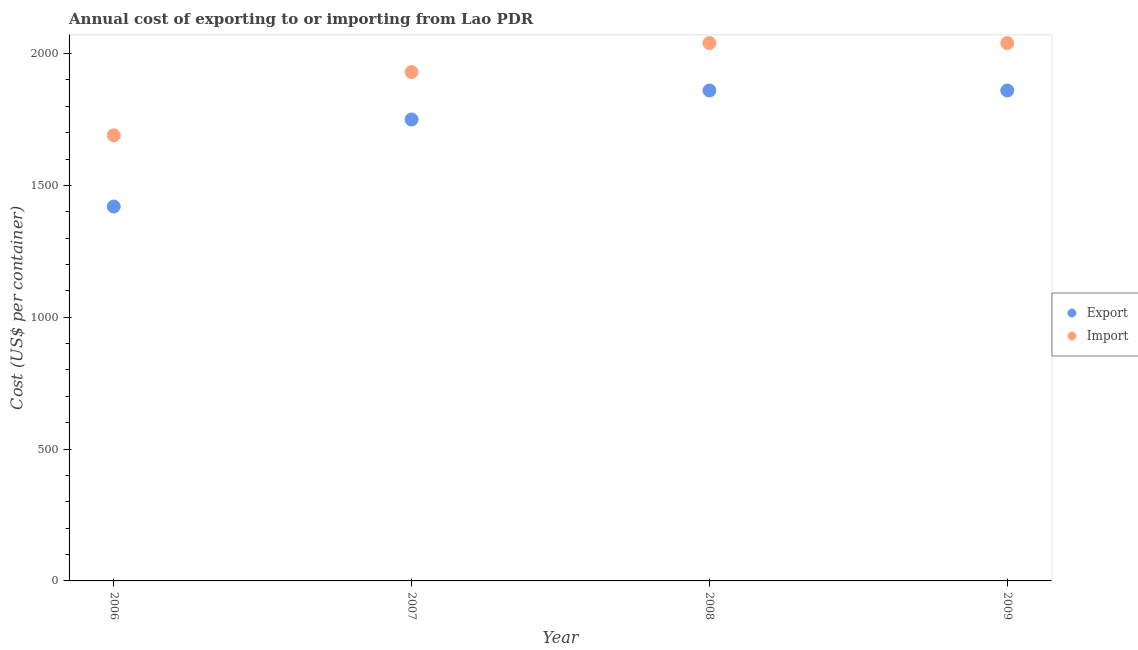How many different coloured dotlines are there?
Your answer should be very brief. 2. Is the number of dotlines equal to the number of legend labels?
Provide a succinct answer. Yes. What is the import cost in 2007?
Offer a very short reply. 1930. Across all years, what is the maximum export cost?
Provide a succinct answer. 1860. Across all years, what is the minimum import cost?
Keep it short and to the point. 1690. In which year was the import cost maximum?
Your answer should be compact. 2008. In which year was the import cost minimum?
Ensure brevity in your answer.  2006. What is the total export cost in the graph?
Keep it short and to the point. 6890. What is the difference between the import cost in 2007 and that in 2008?
Keep it short and to the point. -110. What is the difference between the export cost in 2007 and the import cost in 2009?
Provide a short and direct response. -290. What is the average import cost per year?
Keep it short and to the point. 1925. In the year 2009, what is the difference between the import cost and export cost?
Your response must be concise. 180. What is the ratio of the export cost in 2006 to that in 2007?
Provide a short and direct response. 0.81. Is the difference between the export cost in 2006 and 2009 greater than the difference between the import cost in 2006 and 2009?
Your response must be concise. No. What is the difference between the highest and the second highest import cost?
Your response must be concise. 0. What is the difference between the highest and the lowest import cost?
Provide a succinct answer. 350. In how many years, is the import cost greater than the average import cost taken over all years?
Make the answer very short. 3. Does the import cost monotonically increase over the years?
Give a very brief answer. No. Is the import cost strictly less than the export cost over the years?
Keep it short and to the point. No. What is the difference between two consecutive major ticks on the Y-axis?
Keep it short and to the point. 500. Are the values on the major ticks of Y-axis written in scientific E-notation?
Offer a very short reply. No. Does the graph contain any zero values?
Your answer should be very brief. No. Where does the legend appear in the graph?
Offer a terse response. Center right. How many legend labels are there?
Give a very brief answer. 2. What is the title of the graph?
Make the answer very short. Annual cost of exporting to or importing from Lao PDR. Does "Register a business" appear as one of the legend labels in the graph?
Make the answer very short. No. What is the label or title of the Y-axis?
Make the answer very short. Cost (US$ per container). What is the Cost (US$ per container) of Export in 2006?
Your answer should be compact. 1420. What is the Cost (US$ per container) of Import in 2006?
Offer a very short reply. 1690. What is the Cost (US$ per container) of Export in 2007?
Provide a succinct answer. 1750. What is the Cost (US$ per container) of Import in 2007?
Provide a succinct answer. 1930. What is the Cost (US$ per container) in Export in 2008?
Offer a terse response. 1860. What is the Cost (US$ per container) of Import in 2008?
Provide a succinct answer. 2040. What is the Cost (US$ per container) of Export in 2009?
Your answer should be very brief. 1860. What is the Cost (US$ per container) of Import in 2009?
Ensure brevity in your answer.  2040. Across all years, what is the maximum Cost (US$ per container) of Export?
Your response must be concise. 1860. Across all years, what is the maximum Cost (US$ per container) of Import?
Your answer should be compact. 2040. Across all years, what is the minimum Cost (US$ per container) in Export?
Provide a succinct answer. 1420. Across all years, what is the minimum Cost (US$ per container) in Import?
Offer a very short reply. 1690. What is the total Cost (US$ per container) in Export in the graph?
Your response must be concise. 6890. What is the total Cost (US$ per container) in Import in the graph?
Ensure brevity in your answer.  7700. What is the difference between the Cost (US$ per container) in Export in 2006 and that in 2007?
Provide a succinct answer. -330. What is the difference between the Cost (US$ per container) of Import in 2006 and that in 2007?
Give a very brief answer. -240. What is the difference between the Cost (US$ per container) of Export in 2006 and that in 2008?
Provide a short and direct response. -440. What is the difference between the Cost (US$ per container) of Import in 2006 and that in 2008?
Your answer should be very brief. -350. What is the difference between the Cost (US$ per container) in Export in 2006 and that in 2009?
Provide a succinct answer. -440. What is the difference between the Cost (US$ per container) in Import in 2006 and that in 2009?
Give a very brief answer. -350. What is the difference between the Cost (US$ per container) in Export in 2007 and that in 2008?
Provide a succinct answer. -110. What is the difference between the Cost (US$ per container) in Import in 2007 and that in 2008?
Ensure brevity in your answer.  -110. What is the difference between the Cost (US$ per container) of Export in 2007 and that in 2009?
Your response must be concise. -110. What is the difference between the Cost (US$ per container) in Import in 2007 and that in 2009?
Offer a very short reply. -110. What is the difference between the Cost (US$ per container) of Export in 2008 and that in 2009?
Your answer should be very brief. 0. What is the difference between the Cost (US$ per container) of Export in 2006 and the Cost (US$ per container) of Import in 2007?
Ensure brevity in your answer.  -510. What is the difference between the Cost (US$ per container) of Export in 2006 and the Cost (US$ per container) of Import in 2008?
Make the answer very short. -620. What is the difference between the Cost (US$ per container) of Export in 2006 and the Cost (US$ per container) of Import in 2009?
Offer a very short reply. -620. What is the difference between the Cost (US$ per container) in Export in 2007 and the Cost (US$ per container) in Import in 2008?
Ensure brevity in your answer.  -290. What is the difference between the Cost (US$ per container) in Export in 2007 and the Cost (US$ per container) in Import in 2009?
Ensure brevity in your answer.  -290. What is the difference between the Cost (US$ per container) in Export in 2008 and the Cost (US$ per container) in Import in 2009?
Ensure brevity in your answer.  -180. What is the average Cost (US$ per container) in Export per year?
Your response must be concise. 1722.5. What is the average Cost (US$ per container) in Import per year?
Provide a short and direct response. 1925. In the year 2006, what is the difference between the Cost (US$ per container) in Export and Cost (US$ per container) in Import?
Ensure brevity in your answer.  -270. In the year 2007, what is the difference between the Cost (US$ per container) of Export and Cost (US$ per container) of Import?
Offer a very short reply. -180. In the year 2008, what is the difference between the Cost (US$ per container) in Export and Cost (US$ per container) in Import?
Offer a terse response. -180. In the year 2009, what is the difference between the Cost (US$ per container) in Export and Cost (US$ per container) in Import?
Your answer should be very brief. -180. What is the ratio of the Cost (US$ per container) of Export in 2006 to that in 2007?
Your answer should be very brief. 0.81. What is the ratio of the Cost (US$ per container) in Import in 2006 to that in 2007?
Your answer should be very brief. 0.88. What is the ratio of the Cost (US$ per container) of Export in 2006 to that in 2008?
Provide a succinct answer. 0.76. What is the ratio of the Cost (US$ per container) of Import in 2006 to that in 2008?
Your response must be concise. 0.83. What is the ratio of the Cost (US$ per container) of Export in 2006 to that in 2009?
Provide a short and direct response. 0.76. What is the ratio of the Cost (US$ per container) of Import in 2006 to that in 2009?
Give a very brief answer. 0.83. What is the ratio of the Cost (US$ per container) of Export in 2007 to that in 2008?
Make the answer very short. 0.94. What is the ratio of the Cost (US$ per container) in Import in 2007 to that in 2008?
Make the answer very short. 0.95. What is the ratio of the Cost (US$ per container) of Export in 2007 to that in 2009?
Provide a succinct answer. 0.94. What is the ratio of the Cost (US$ per container) of Import in 2007 to that in 2009?
Provide a succinct answer. 0.95. What is the difference between the highest and the second highest Cost (US$ per container) in Export?
Your response must be concise. 0. What is the difference between the highest and the lowest Cost (US$ per container) in Export?
Your answer should be very brief. 440. What is the difference between the highest and the lowest Cost (US$ per container) of Import?
Offer a terse response. 350. 